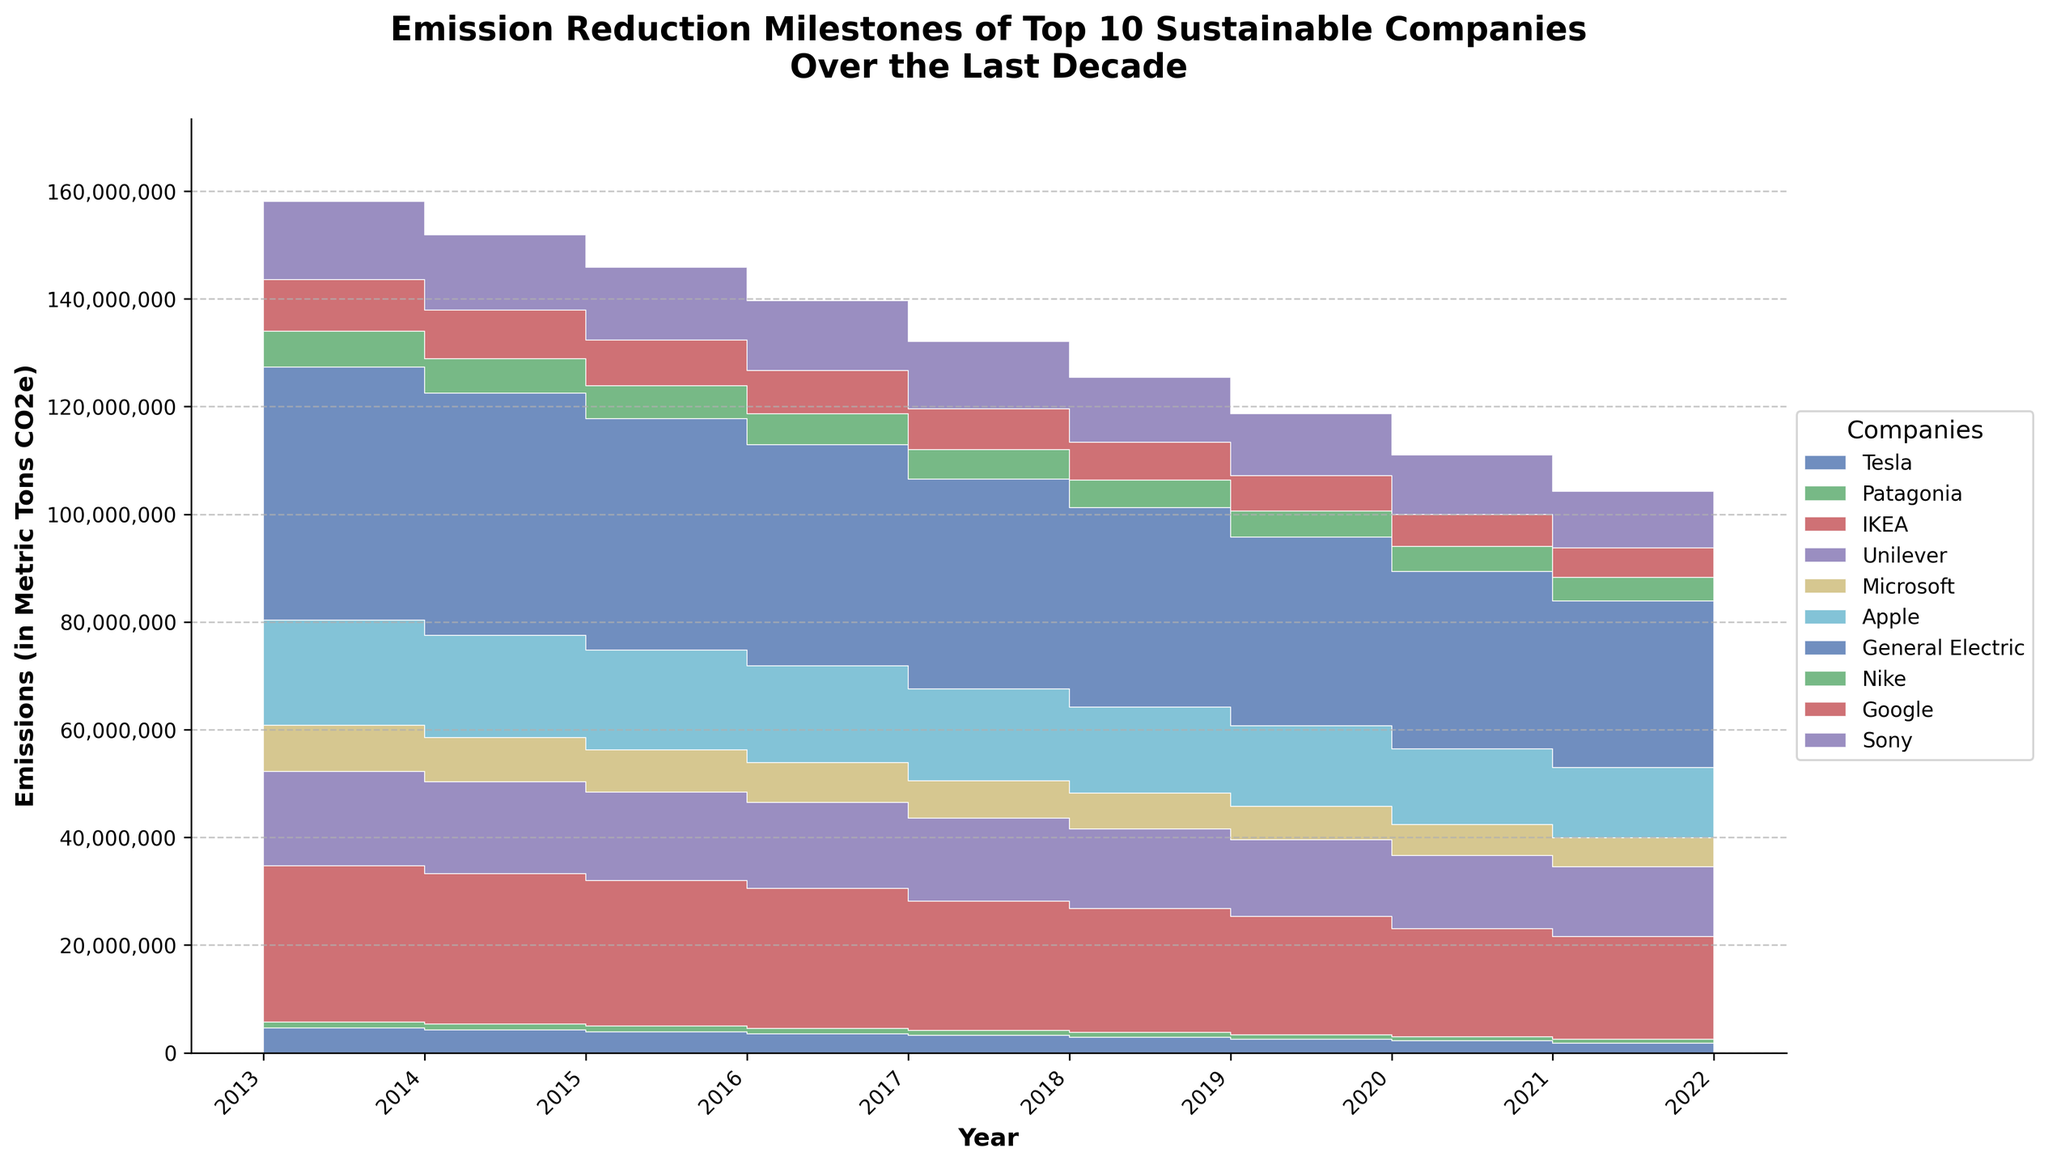What is the title of the chart? The title is located at the top of the chart and provides a brief overview of the data being represented. It usually summarizes the main idea or focus of the visual representation.
Answer: Emission Reduction Milestones of Top 10 Sustainable Companies Over the Last Decade Which company had the highest emissions in 2013? To determine this, look at the height of each step area segment in 2013 on the x-axis and compare their values. General Electric's area is the highest in 2013.
Answer: General Electric How did Tesla's emissions change from 2013 to 2022? Examine the step area segment corresponding to Tesla over the given years. Notice the trend showing a consistent decrease in Tesla's emissions over the decade.
Answer: Decreased Which company had the smallest reduction in emissions over the decade? To figure this out, calculate the difference in emissions from 2013 to 2022 for each company and compare them. General Electric had the smallest reduction (from 50,000,000 to 31,000,000 metric tons CO2e).
Answer: General Electric What was the total emissions reduction for Microsoft from 2013 to 2022? Subtract the emissions value of 2022 from that of 2013 for Microsoft: 9,000,000 - 5,400,000 = 3,600,000 metric tons CO2e.
Answer: 3,600,000 metric tons CO2e Which company had the sharpest reduction in emissions in a single year? Identify the single year where the largest vertical drop in a step area segment occurs for any company. IKEA from 2017 to 2018 shows a significant drop.
Answer: IKEA Between 2017 and 2020, which company showed the most consistent reduction in emissions each year? Check each company's step area over these years and identify the one with the most uniform decline. Tesla shows a consistent reduction in emissions every year between 2017 and 2020.
Answer: Tesla How many companies achieved a reduction in emissions every year for the decade? Count the number of companies whose step area consistently decreases from 2013 to 2022 without any increase. Tesla, Patagonia, and IKEA maintained a consistent reduction throughout the decade.
Answer: Three companies Which company saw a larger reduction in emissions: Nike or Google? Calculate the reduction in emissions for both companies from 2013 to 2022. Nike: 7,000,000 - 4,300,000 = 2,700,000 and Google: 10,000,000 - 5,500,000 = 4,500,000. Google had a larger reduction.
Answer: Google In what year did Unilever first reduce its emissions to below 16,000,000 metric tons CO2e? Locate the step where Unilever's emissions drop below 16,000,000 on the y-axis. This occurs in the year 2018.
Answer: 2018 